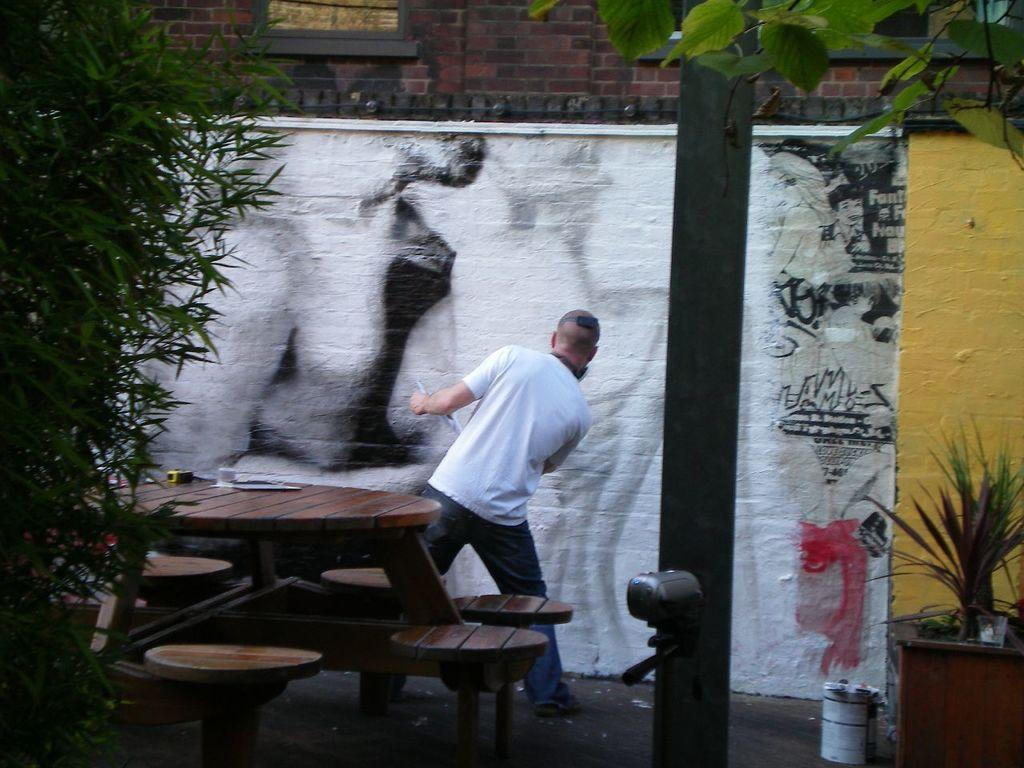What type of furniture is present in the image? There is a table and chairs around the table in the image. What is the person wearing in the image? The person is wearing a white t-shirt. What can be seen in the background of the image? There is a building with a window and plants visible in the image. What other natural elements are present in the image? There is a tree in the image. What type of decoration is present on a wall in the image? A painting is present on a wall in the image. What type of yoke is being used to carry the painting in the image? There is no yoke present in the image, nor is there any indication that the painting is being carried. What degree of difficulty is the person facing in the image? The image does not depict any challenges or difficulties that the person might be facing, so it is not possible to determine a degree of difficulty. 